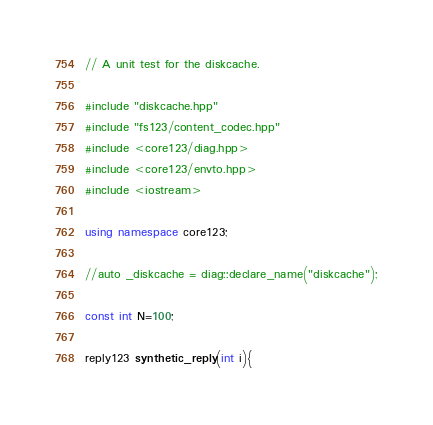Convert code to text. <code><loc_0><loc_0><loc_500><loc_500><_C++_>// A unit test for the diskcache.

#include "diskcache.hpp"
#include "fs123/content_codec.hpp"
#include <core123/diag.hpp>
#include <core123/envto.hpp>
#include <iostream>

using namespace core123;

//auto _diskcache = diag::declare_name("diskcache");

const int N=100;

reply123 synthetic_reply(int i){</code> 